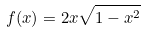Convert formula to latex. <formula><loc_0><loc_0><loc_500><loc_500>f ( x ) = 2 x \sqrt { 1 - x ^ { 2 } }</formula> 